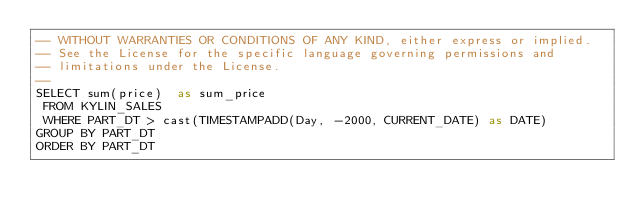Convert code to text. <code><loc_0><loc_0><loc_500><loc_500><_SQL_>-- WITHOUT WARRANTIES OR CONDITIONS OF ANY KIND, either express or implied.
-- See the License for the specific language governing permissions and
-- limitations under the License.
--
SELECT sum(price)  as sum_price
 FROM KYLIN_SALES
 WHERE PART_DT > cast(TIMESTAMPADD(Day, -2000, CURRENT_DATE) as DATE)
GROUP BY PART_DT
ORDER BY PART_DT</code> 